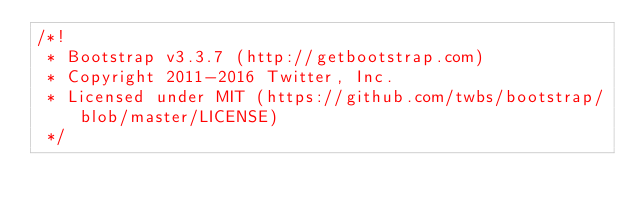Convert code to text. <code><loc_0><loc_0><loc_500><loc_500><_CSS_>/*!
 * Bootstrap v3.3.7 (http://getbootstrap.com)
 * Copyright 2011-2016 Twitter, Inc.
 * Licensed under MIT (https://github.com/twbs/bootstrap/blob/master/LICENSE)
 */</code> 